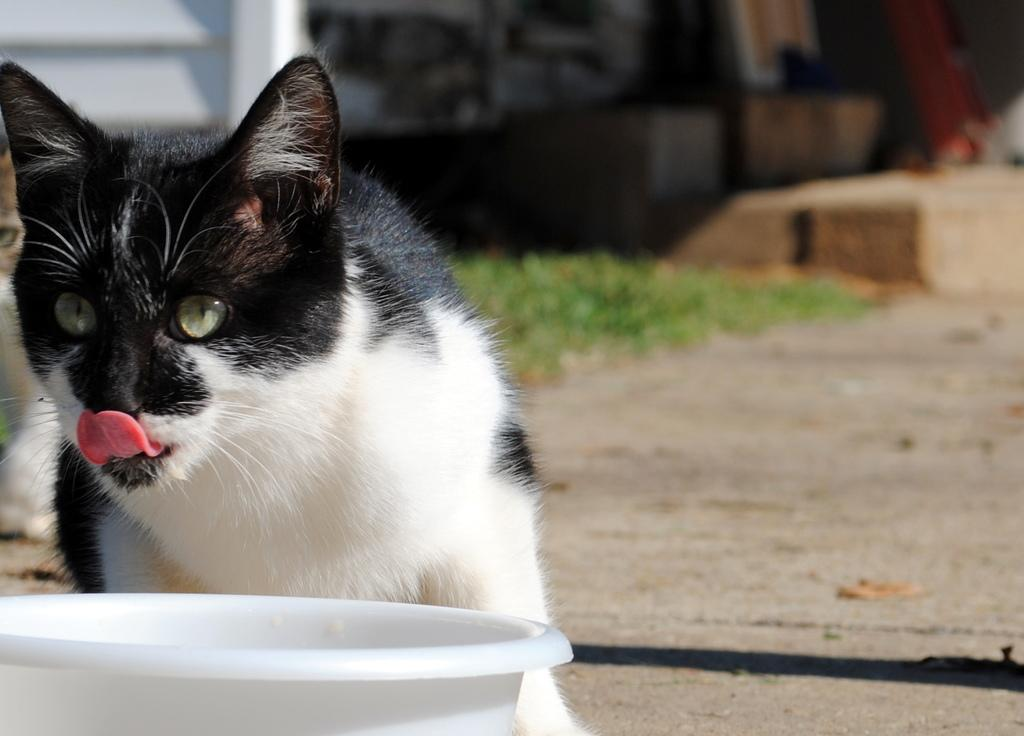What type of animal can be seen on the left side of the image? There is a cat on the left side of the image. What is the color of the object next to the cat? There is a white object on the left side of the image. How would you describe the background of the image? The background has a blurred view. Can you spot another cat in the image? Yes, there is another cat in the image. What type of natural environment is visible in the image? There is grass in the image. What type of pathway is present in the image? There is a walkway in the image. What other objects can be seen in the image besides the cats and the white object? There are other objects in the image. What type of hat is the cat wearing in the image? There is no hat present in the image; the cat is not wearing any clothing. 